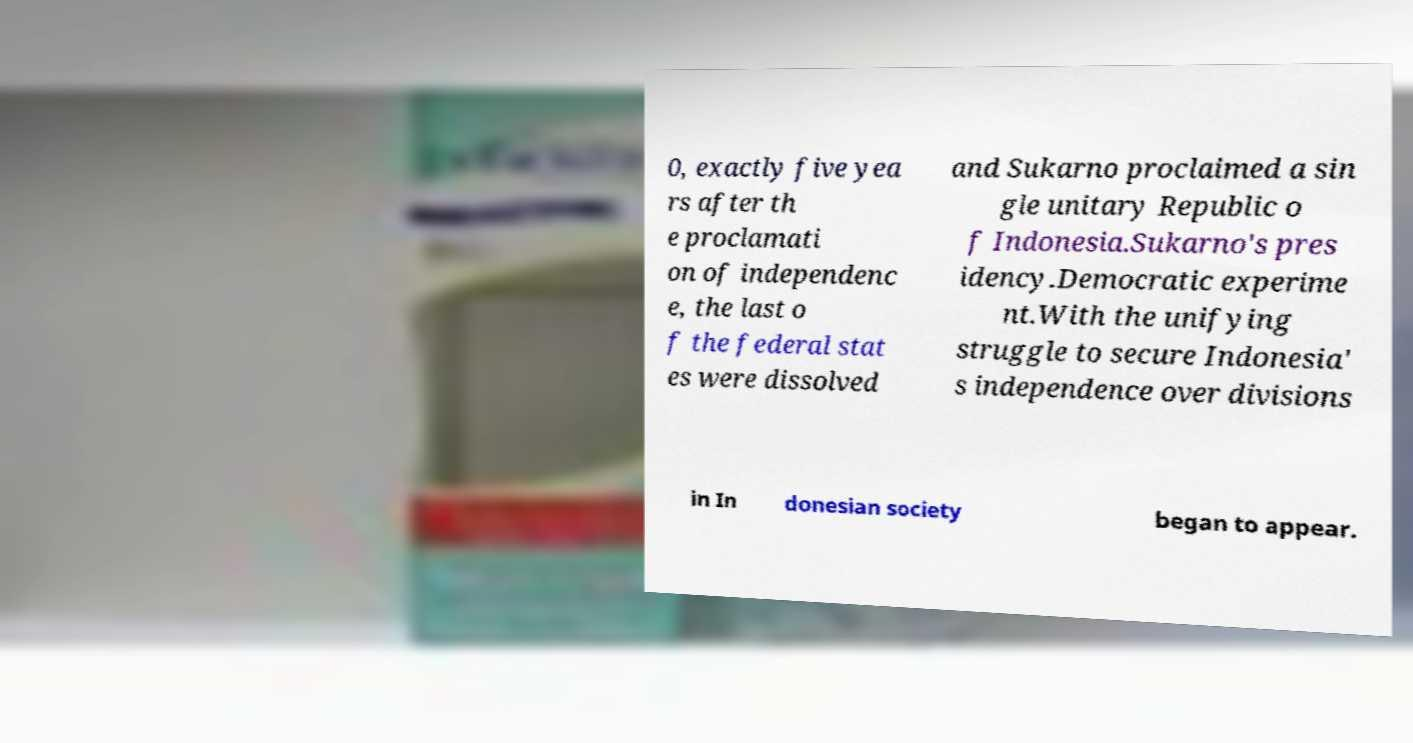Can you read and provide the text displayed in the image?This photo seems to have some interesting text. Can you extract and type it out for me? 0, exactly five yea rs after th e proclamati on of independenc e, the last o f the federal stat es were dissolved and Sukarno proclaimed a sin gle unitary Republic o f Indonesia.Sukarno's pres idency.Democratic experime nt.With the unifying struggle to secure Indonesia' s independence over divisions in In donesian society began to appear. 